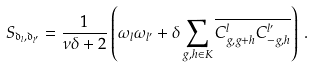<formula> <loc_0><loc_0><loc_500><loc_500>S _ { \mathfrak { d } _ { l } , \mathfrak { d } _ { l ^ { \prime } } } = \frac { 1 } { \nu \delta + 2 } \left ( \omega _ { l } \omega _ { l ^ { \prime } } + \delta \sum _ { g , h \in K } \overline { C ^ { l } _ { g , g + h } C ^ { l ^ { \prime } } _ { - g , h } } \right ) \, .</formula> 